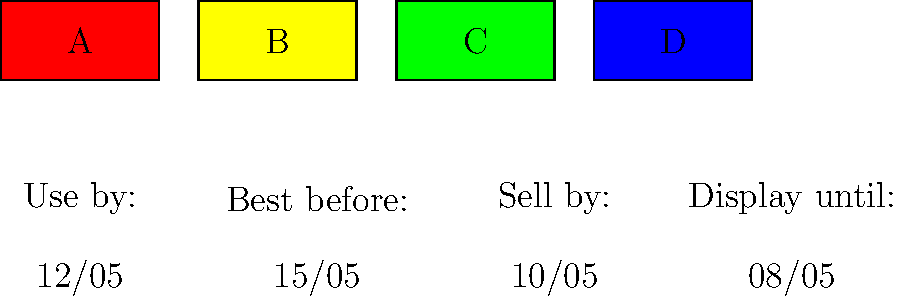As a conscientious British consumer, which food safety label would you prioritize when purchasing perishable items to ensure the highest level of food safety? To determine the most important food safety label for perishable items, let's examine each label:

1. Label A (red): "Use by: 12/05"
   This is the most critical for food safety. It indicates the date by which the food must be consumed to avoid health risks.

2. Label B (yellow): "Best before: 15/05"
   This refers to food quality rather than safety. Food may still be safe to eat after this date but may not be at its best quality.

3. Label C (green): "Sell by: 10/05"
   This is for stock rotation in stores and doesn't directly relate to food safety for consumers.

4. Label D (blue): "Display until: 08/05"
   Similar to "Sell by," this is for shop staff and doesn't indicate safety for consumers.

The "Use by" date is the only one that explicitly relates to food safety. As a British consumer concerned about food safety, this should be the priority when purchasing perishable items.
Answer: "Use by" date 